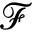Convert formula to latex. <formula><loc_0><loc_0><loc_500><loc_500>\mathcal { F }</formula> 